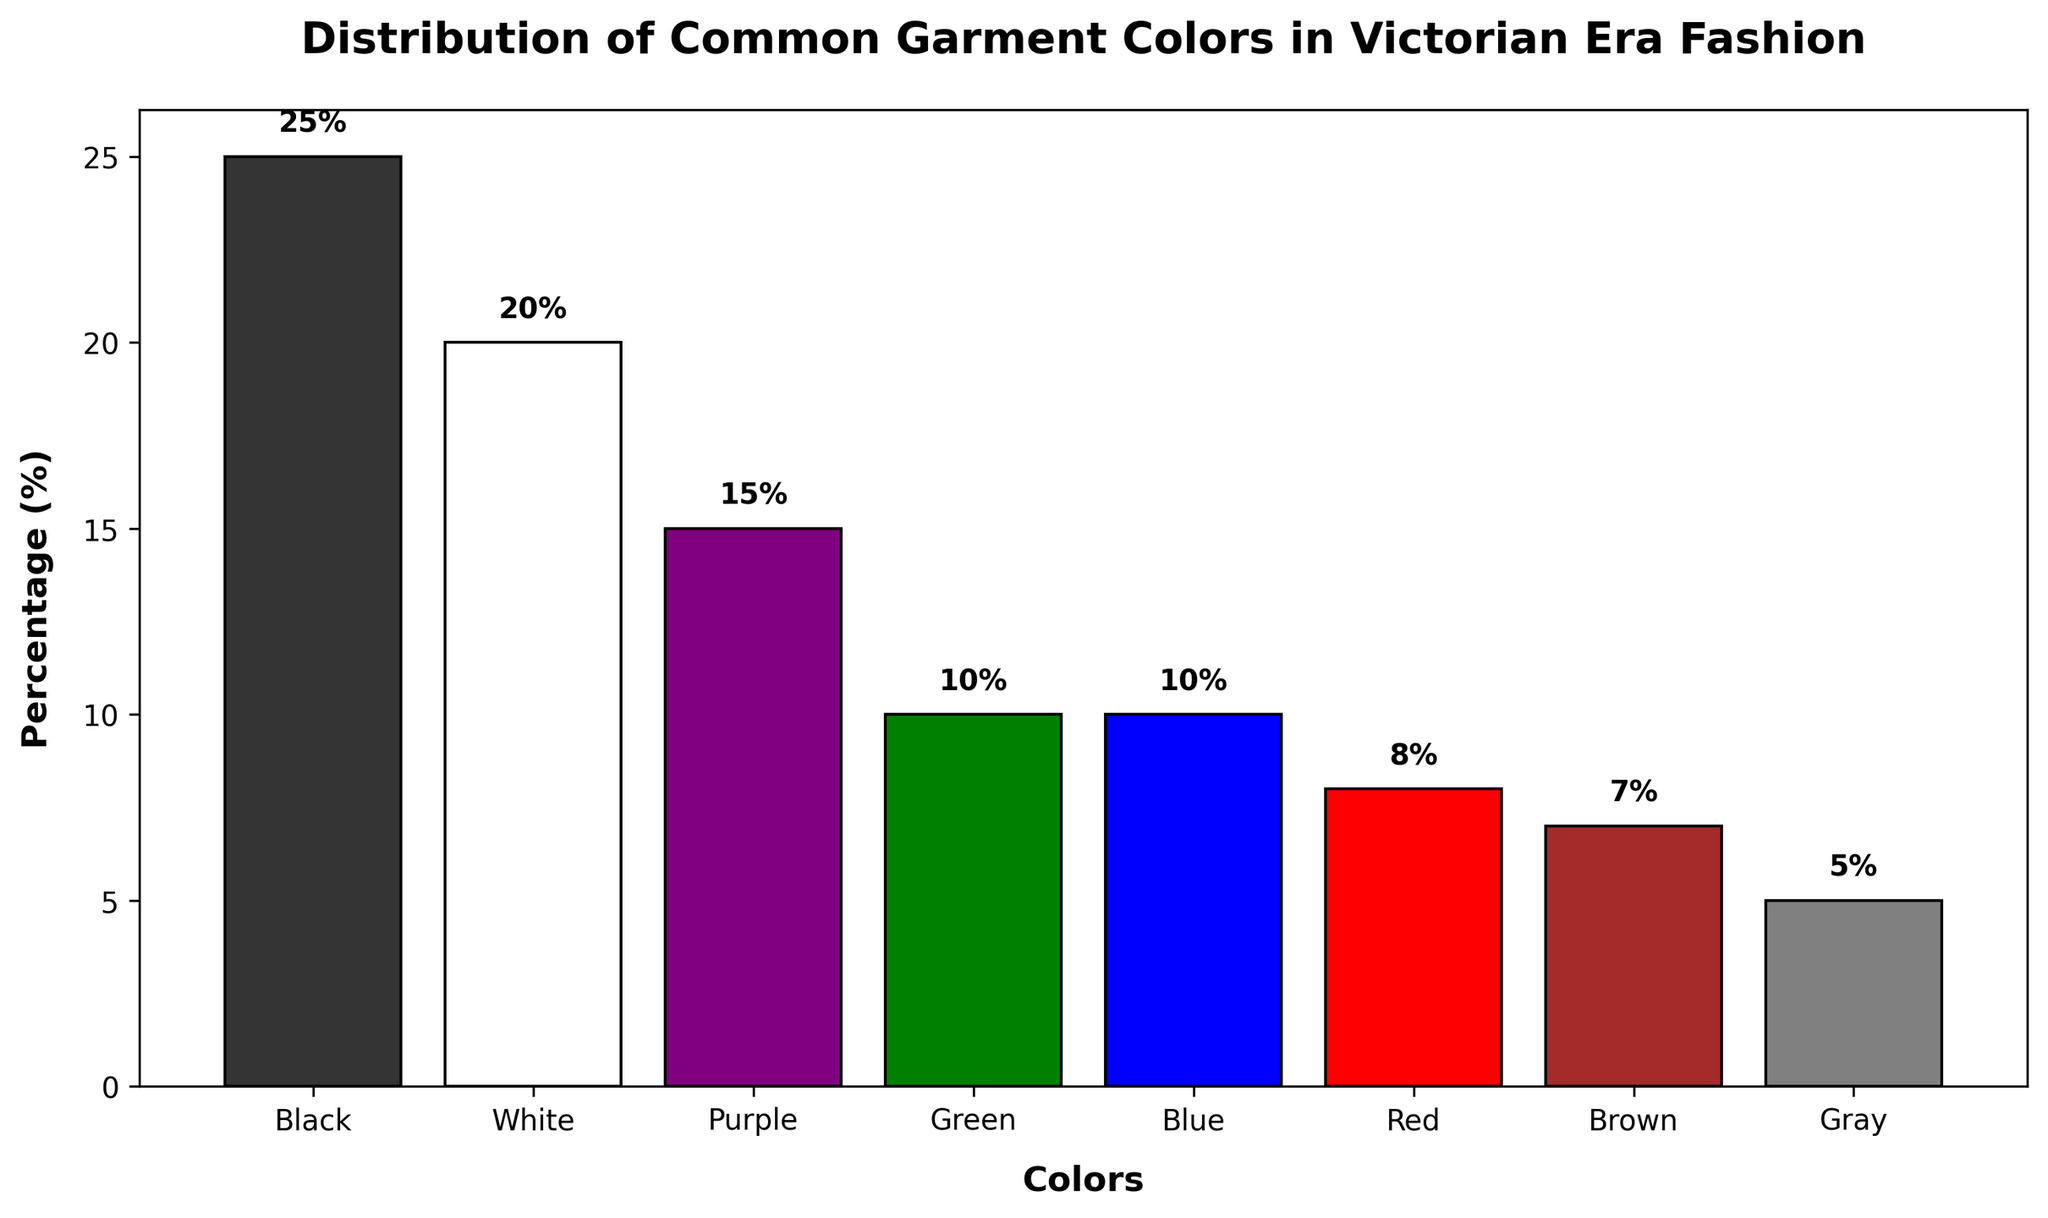What color had the highest percentage in Victorian Era fashion? The bar chart shows different colors and their corresponding percentages. The highest bar corresponds to Black with a percentage of 25%.
Answer: Black Which two colors had equal percentages and what were those percentages? The chart shows two colors, Green and Blue, with their bars at the same height. Both have percentages of 10%.
Answer: Green and Blue at 10% What is the combined percentage of White and Purple? The percentages for White and Purple are 20% and 15% respectively. Adding these together gives 20% + 15% = 35%.
Answer: 35% Which color category represents exactly one-fourth of the distribution? The bar representing Black reaches up to 25%, which is one-fourth of 100%.
Answer: Black Are there more colors with percentages above 10% or below 10%? There are four colors above 10% (Black, White, Purple, and Green) and four colors below 10% (Blue, Red, Brown, and Gray). Therefore, they are equal in number.
Answer: Equal Which color has the smallest representation in the chart? The color with the smallest bar height is Gray, which is at 5%.
Answer: Gray What is the difference in percentage between Red and Brown? The percentage for Red is 8% and for Brown is 7%. Subtracting these gives 8% - 7% = 1%.
Answer: 1% How does the percentage of Black compare to the percentage of Red and Blue combined? Black is at 25%, while Red and Blue together sum to 8% + 10% = 18%. Therefore, Black is greater than the sum of Red and Blue.
Answer: Greater What is the median percentage of the colors? Listing the percentages in order: 5, 7, 8, 10, 10, 15, 20, 25. The median values are 10 and 10, so the median percentage is the average of these two values, which is (10 + 10) / 2 = 10%.
Answer: 10% What percentage of the total does the sum of Gray, Brown, and Red make up? Summing the percentages: 5% (Gray) + 7% (Brown) + 8% (Red) = 20%.
Answer: 20% 